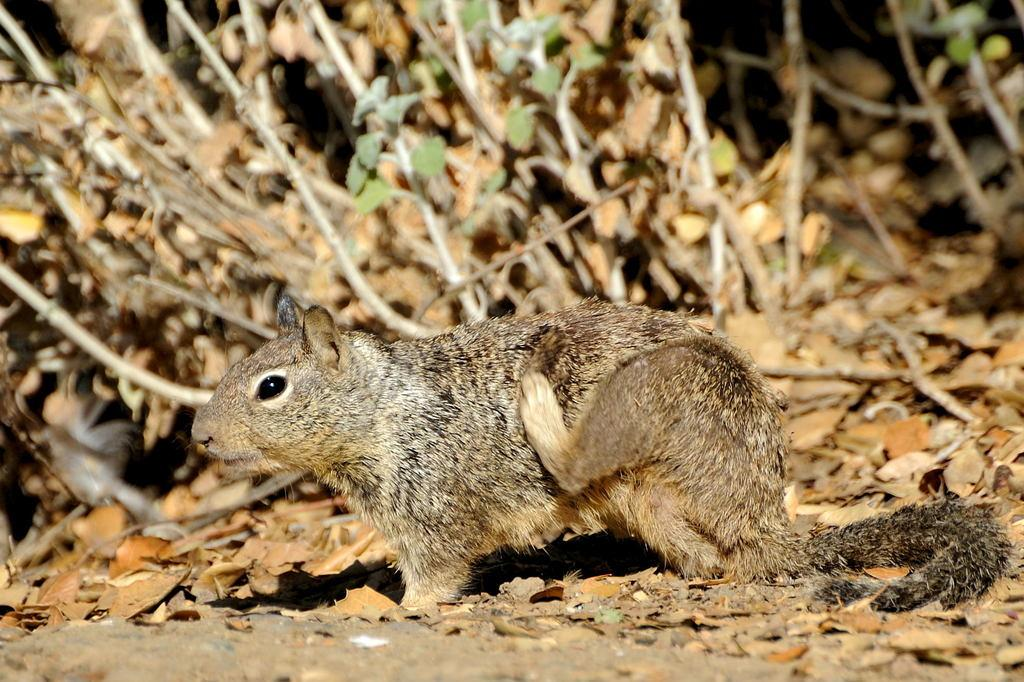What animal is on the ground in the image? There is a squirrel on the ground in the image. What type of natural material is visible in the image? There are dry leaves visible in the image. What type of vegetation is present in the image? There are plants in the image. What type of representative is present in the image? There is no representative present in the image; it features a squirrel, dry leaves, and plants. Can you see a zebra in the image? No, there is no zebra present in the image. 